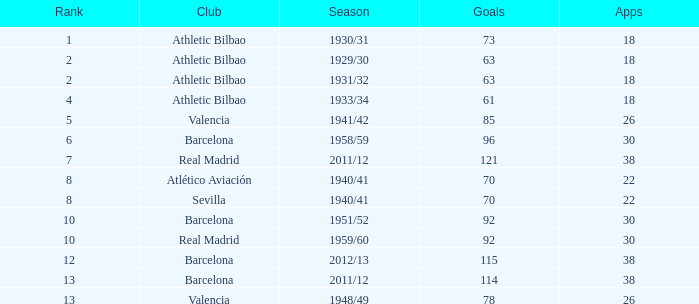Which team participated in less than 22 events and held a position below 2nd place? Athletic Bilbao. 